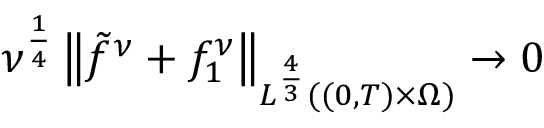<formula> <loc_0><loc_0><loc_500><loc_500>\nu ^ { \frac { 1 } { 4 } } \left \| \tilde { f } ^ { \nu } + f _ { 1 } ^ { \nu } \right \| _ { L ^ { \frac { 4 } { 3 } } ( ( 0 , T ) \times \Omega ) } \to 0</formula> 